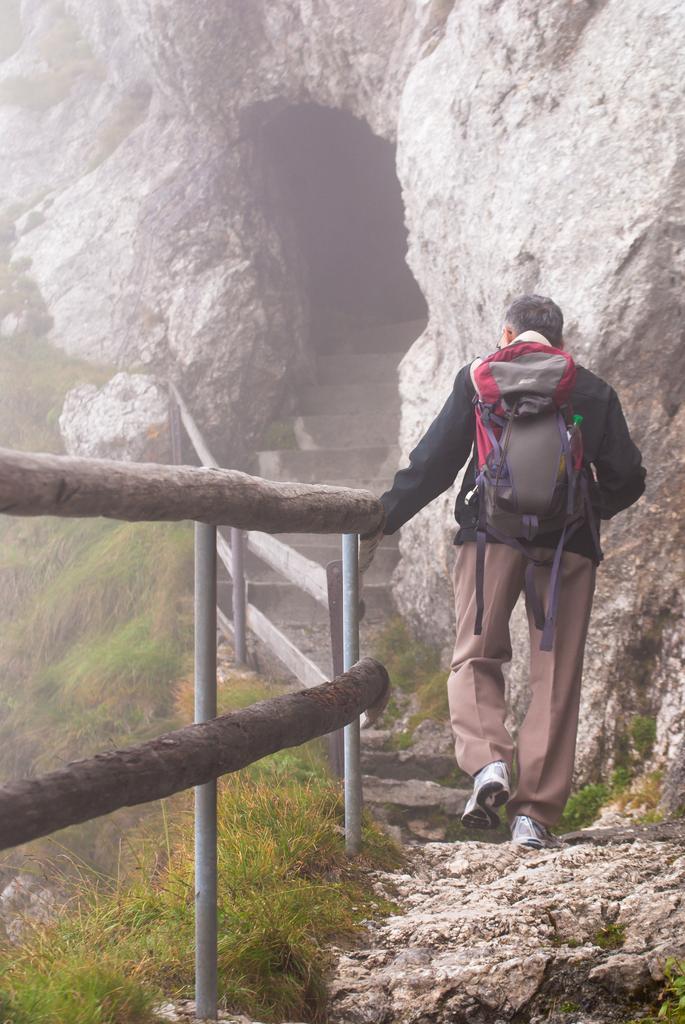Can you describe this image briefly? Here we can see a person wore bag. Beside this person there is a fence and grass. This is cave. 